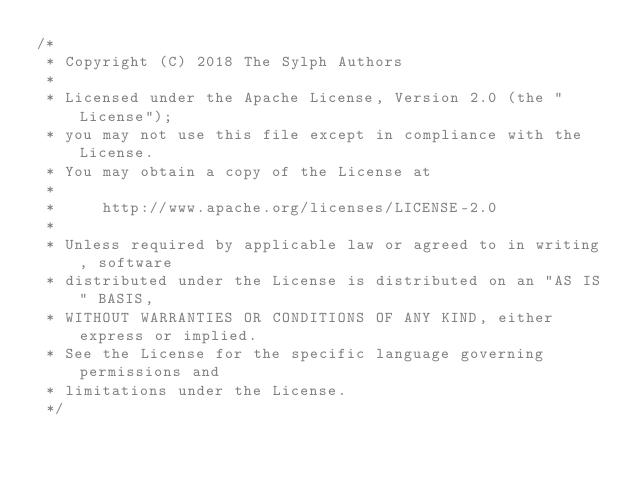Convert code to text. <code><loc_0><loc_0><loc_500><loc_500><_Java_>/*
 * Copyright (C) 2018 The Sylph Authors
 *
 * Licensed under the Apache License, Version 2.0 (the "License");
 * you may not use this file except in compliance with the License.
 * You may obtain a copy of the License at
 *
 *     http://www.apache.org/licenses/LICENSE-2.0
 *
 * Unless required by applicable law or agreed to in writing, software
 * distributed under the License is distributed on an "AS IS" BASIS,
 * WITHOUT WARRANTIES OR CONDITIONS OF ANY KIND, either express or implied.
 * See the License for the specific language governing permissions and
 * limitations under the License.
 */</code> 